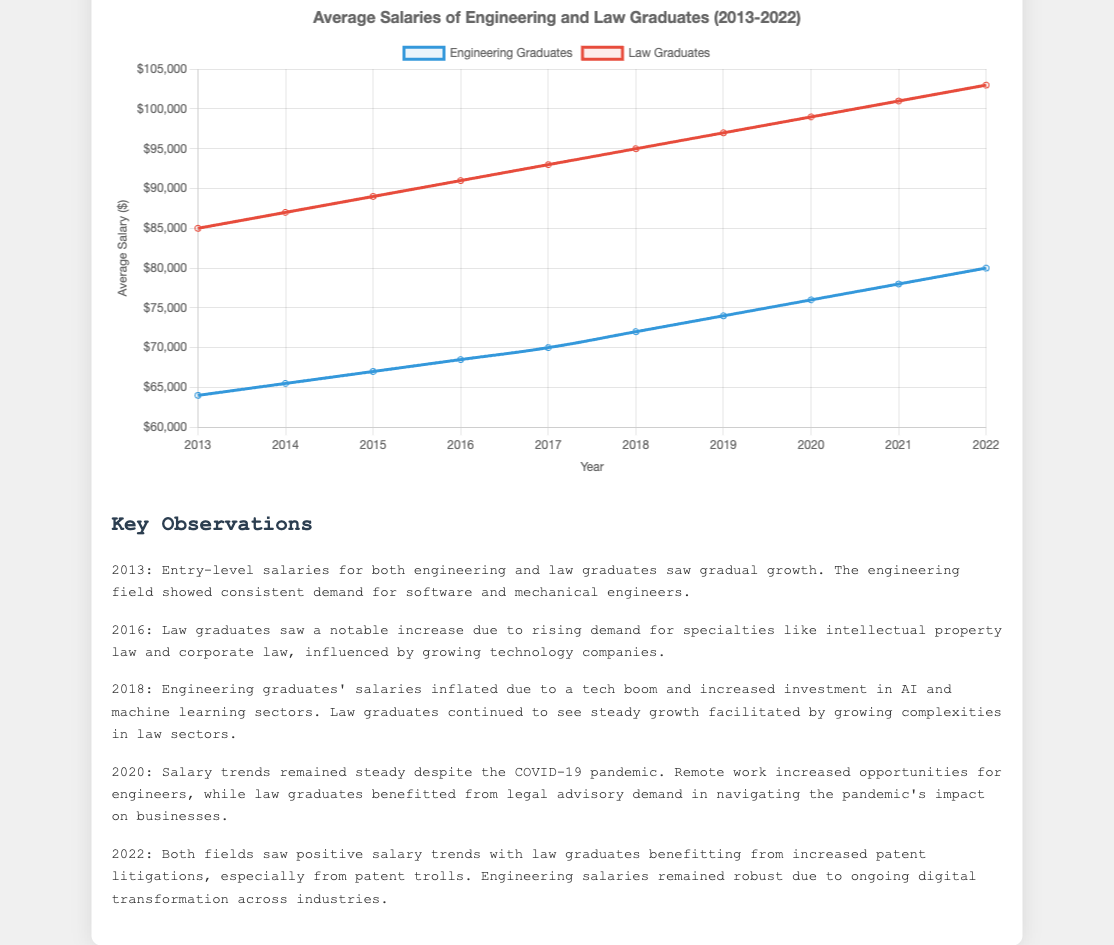Which graduate group had a higher average salary in 2013? Looking at the 2013 data points in the figure, the educational background of the graduates is given, and law graduates had a higher average salary than engineering graduates.
Answer: law graduates How much did the average salary for engineering graduates increase from 2013 to 2022? To find this, subtract the 2013 average salary of engineering graduates ($64,000) from the 2022 average salary ($80,000).
Answer: $16,000 Which year saw the most significant salary increase for law graduates? By examining the plot, we can track the yearly increments of the law graduates' salary. The most noticeable increase appears between 2015 and 2016.
Answer: 2016 What is the combined average salary of engineering graduates and law graduates in 2022? Sum the average salaries of both groups in 2022: engineering graduates ($80,000) and law graduates ($103,000), then compute the average: \((80,000 + 103,000) / 2\).
Answer: $91,500 Did the average salary growth rate for engineering graduates appear steady or fluctuate over the decade? The visual trend line for engineering graduates shows a consistent upward slope with steady increments yearly.
Answer: steady What were the salaries for law graduates and engineering graduates in 2018? Which field had a higher salary? From the plot, the 2018 salary for engineering graduates was $72,000 and for law graduates was $95,000. Law graduates had a higher salary.
Answer: law graduates In which year did engineering graduates see a salary reach or surpass $70,000? Referring to the plot, engineering graduates reached a salary of $70,000 in 2017.
Answer: 2017 How did the COVID-19 pandemic affect the salary trends for both engineering and law graduates? The commentary under the pandemic year (2020) indicates that the salary trends remained steady for both job fields.
Answer: steady What was the difference in salary between law graduates and engineering graduates in 2020? Subtract the 2020 salary of engineering graduates ($76,000) from the 2020 salary of law graduates ($99,000).
Answer: $23,000 What visual attribute distinguishes the salary trends of engineering graduates from law graduates on the plot? The line for engineering graduates is colored blue and the line for law graduates is colored red. Additionally, the red line is positioned higher due to generally higher salaries for law graduates.
Answer: color and positioning 